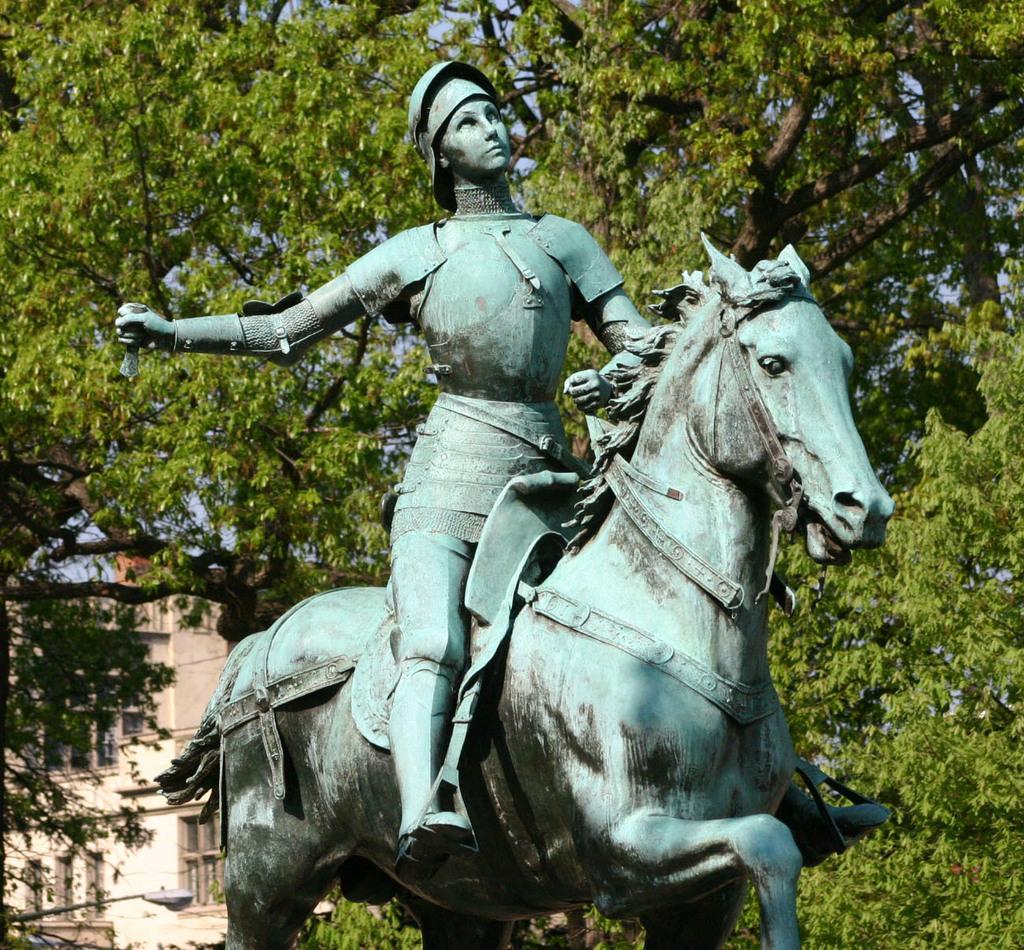Please provide a concise description of this image. In this image we can see there is a statue of a person riding the horse. In the background there are trees and a building. 